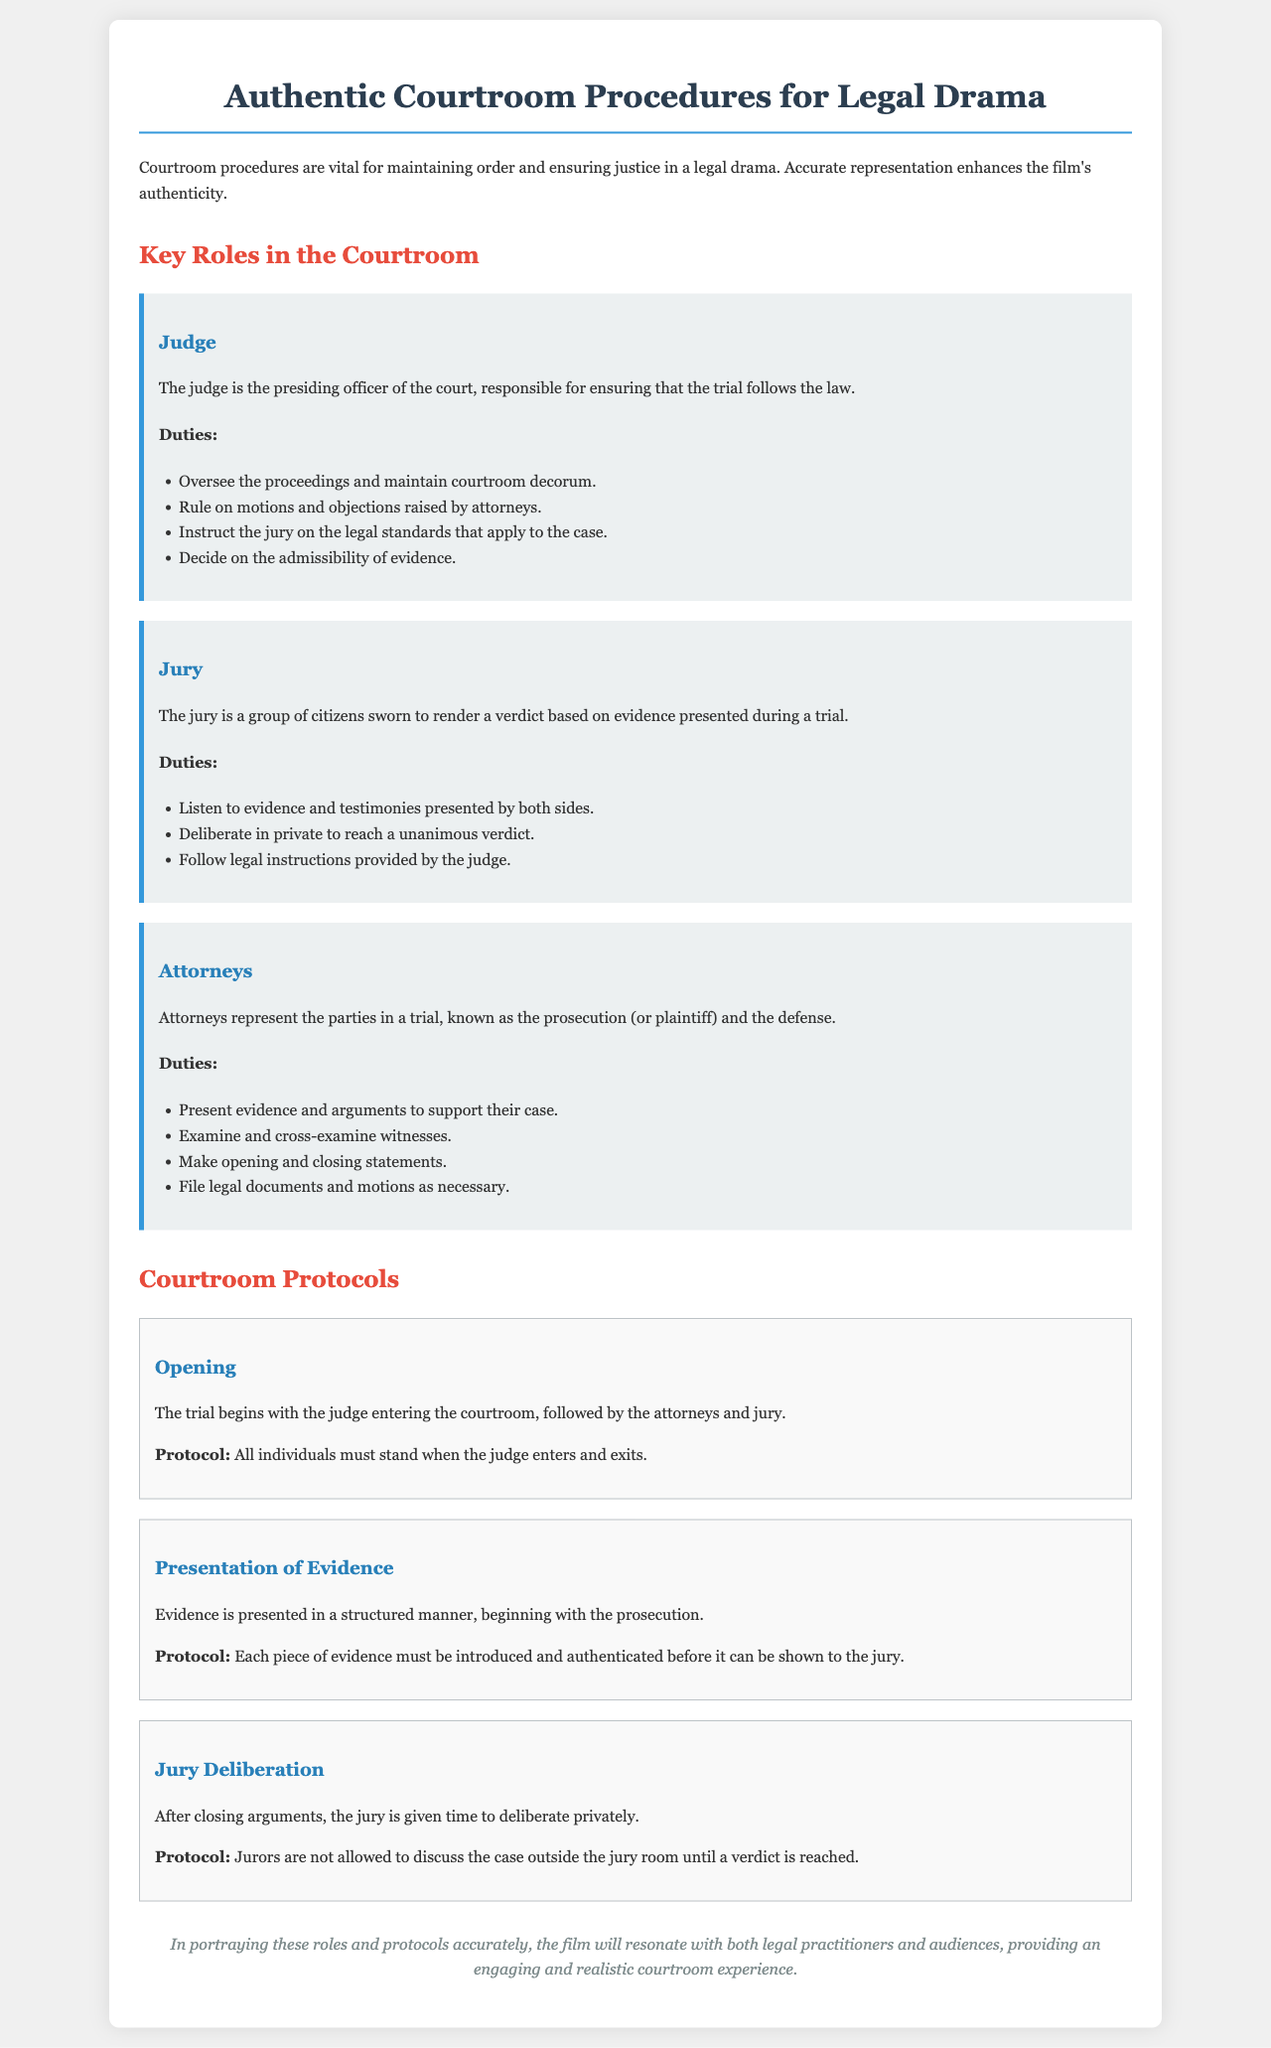What is the role of the judge? The judge is the presiding officer of the court, responsible for ensuring that the trial follows the law.
Answer: Presiding officer What must individuals do when the judge enters? The protocol states that all individuals must stand when the judge enters and exits.
Answer: Stand How many duties does the attorney have listed? The duties of the attorney include several points; counting these gives the total amount.
Answer: Four What is the duty of the jury during deliberation? The duty of the jury is to deliberate in private to reach a unanimous verdict.
Answer: Deliberate privately What happens after closing arguments? After closing arguments, the jury is given time to deliberate privately.
Answer: Jury deliberation How is evidence presented in a courtroom? Evidence is presented in a structured manner, beginning with the prosecution.
Answer: Structured manner What do jurors need to follow according to the judge's instructions? Jurors are instructed to follow legal instructions provided by the judge.
Answer: Legal instructions What is the first action that happens in a trial? The trial begins with the judge entering the courtroom, followed by attorneys and the jury.
Answer: Judge entering What do attorneys do during a trial? Attorneys represent the parties in a trial, known as the prosecution (or plaintiff) and the defense.
Answer: Represent parties 